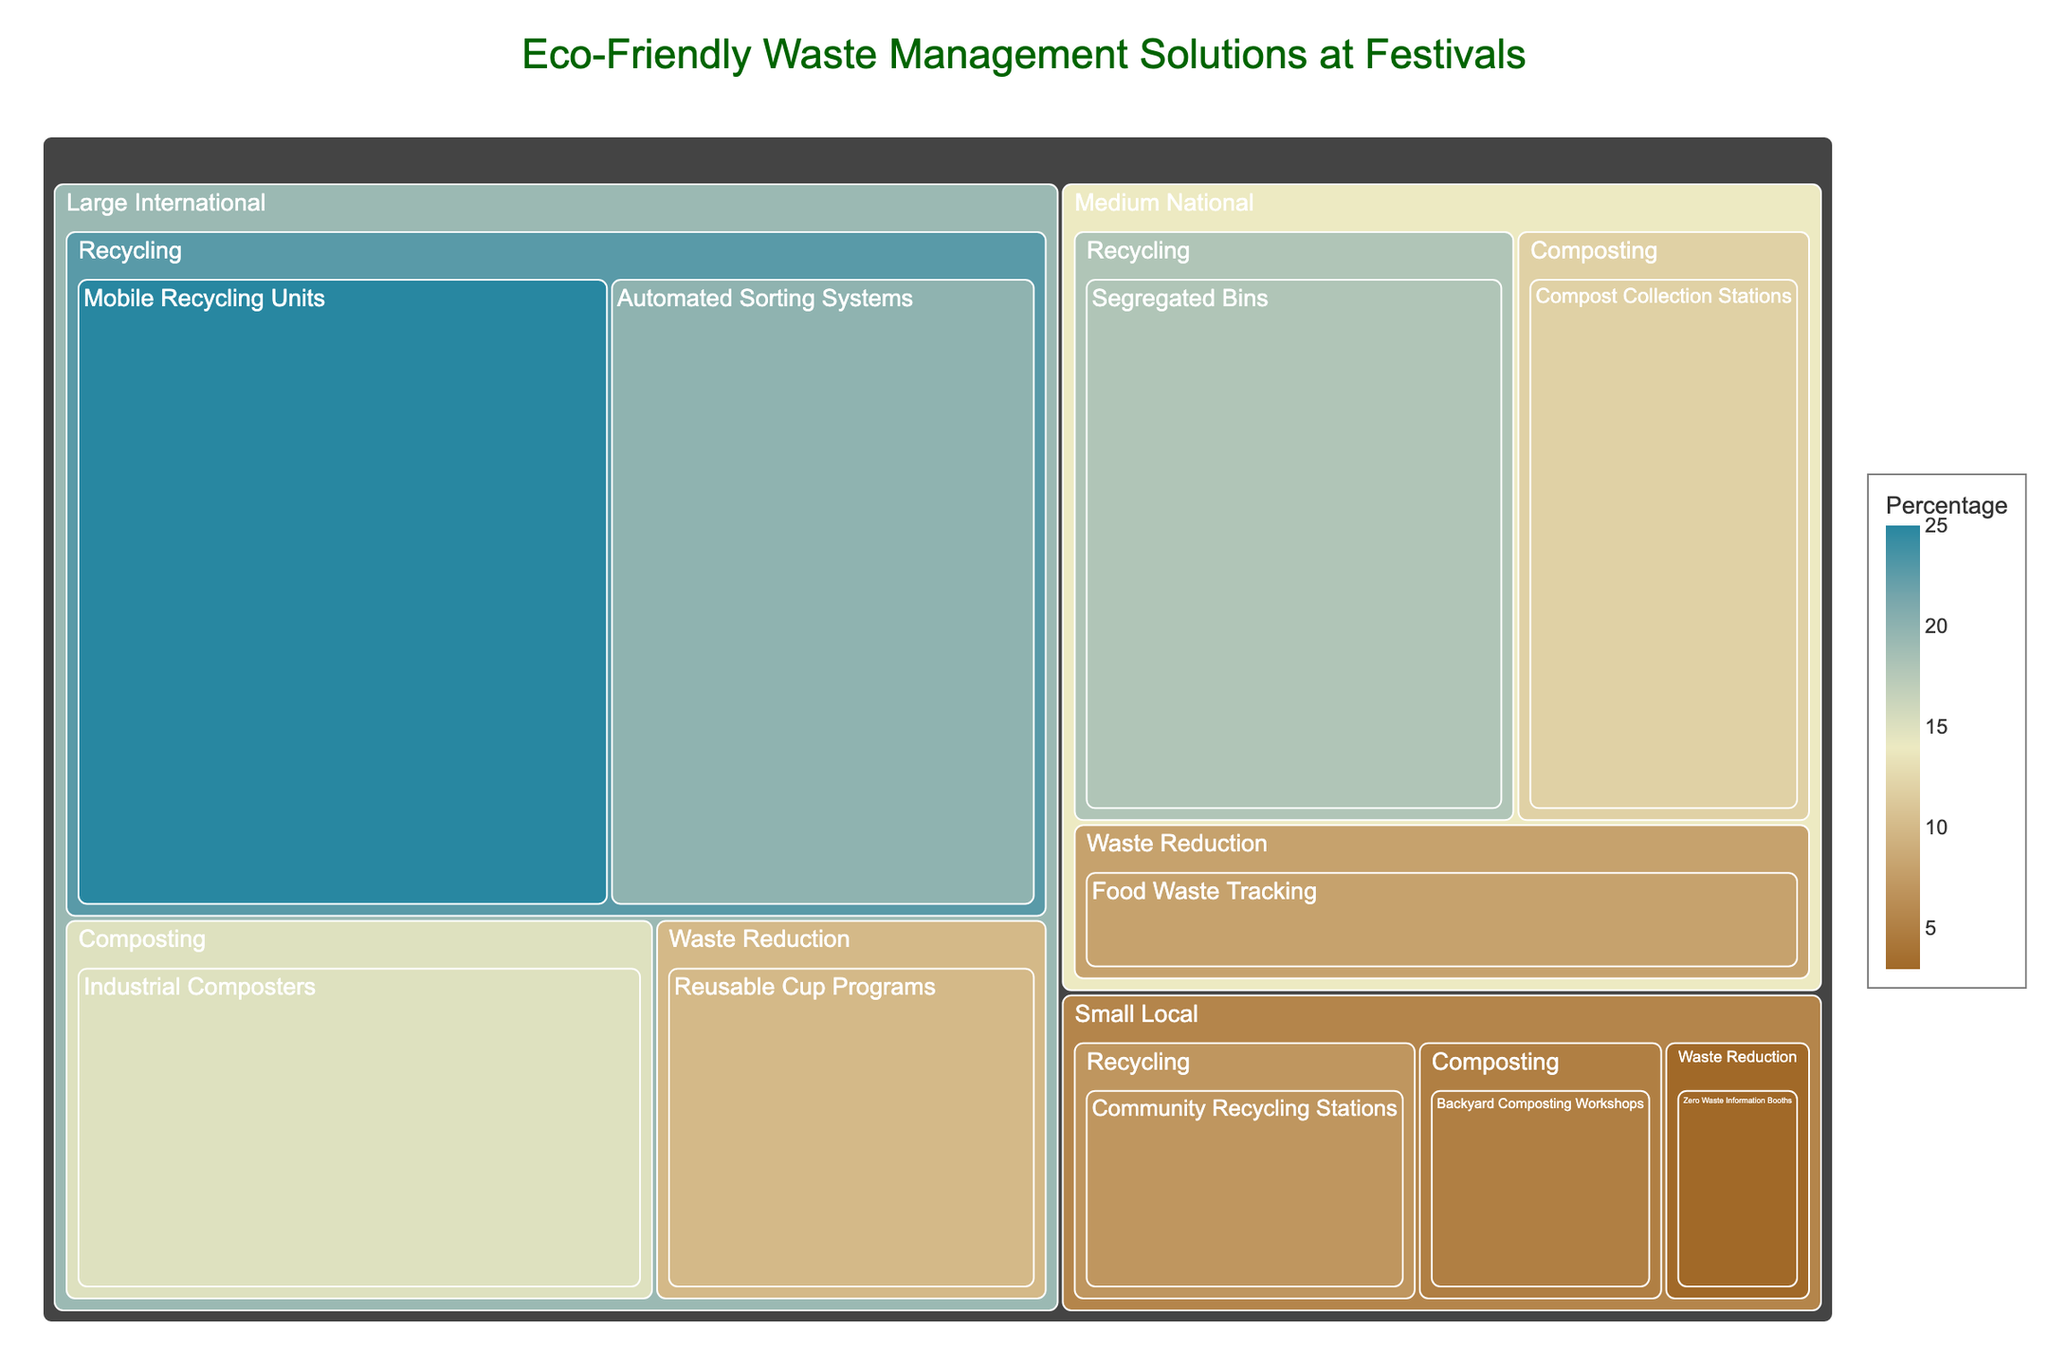what is the title of the treemap? The title is typically located at the top of the treemap. In this case, the title "Eco-Friendly Waste Management Solutions at Festivals" is clearly displayed.
Answer: Eco-Friendly Waste Management Solutions at Festivals How much percentage does 'Automated Sorting Systems' contribute to Large International festivals? Locate the 'Large International' group in the treemap, then identify the segment corresponding to 'Recycling', and finally find 'Automated Sorting Systems'. The percentage is displayed within the segment.
Answer: 20% Which solution has the highest percentage allocation in Medium National festivals? Locate the 'Medium National' group, check the percentages for each solution under 'Recycling', 'Composting', and 'Waste Reduction', and identify the highest value. The highest percentage is for 'Segregated Bins'.
Answer: Segregated Bins How do the total percentages for Recycling compare between Large International and Small Local festivals? Sum the percentages of all 'Recycling' solutions for Large International (25% + 20% = 45%) and compare it to the sum for Small Local (7%).
Answer: Large International has 38% more What is the combined percentage of Waste Reduction solutions across all festival sizes? Add the percentages for 'Waste Reduction' solutions in Large International (10%), Medium National (8%), and Small Local (3%). The sum is 10% + 8% + 3% = 21%.
Answer: 21% Which festival size has the least allocation for Composting solutions? Identify the segments for 'Composting' across all festival sizes and compare their percentages. Small Local has the smallest total with 5%.
Answer: Small Local What is the total percentage allocation for all solutions in Large International festivals? Add the percentages of all solutions in Large International: 25% + 20% + 15% + 10%. The sum is 25% + 20% + 15% + 10% = 70%.
Answer: 70% What solution has the smallest percentage allocation in the entire treemap? Identify the segment with the smallest displayed percentage across all categories and sizes. 'Zero Waste Information Booths' in Small Local has the smallest percentage.
Answer: Zero Waste Information Booths 